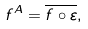<formula> <loc_0><loc_0><loc_500><loc_500>f ^ { A } = \overline { f \circ \varepsilon } ,</formula> 